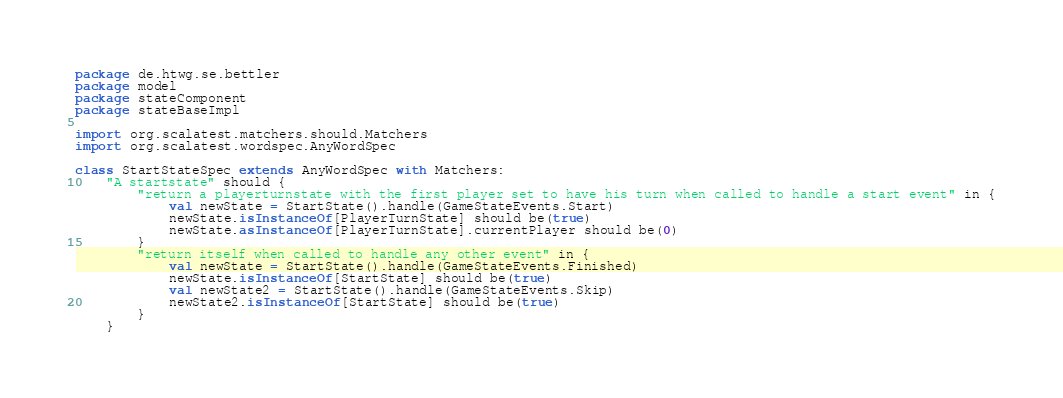Convert code to text. <code><loc_0><loc_0><loc_500><loc_500><_Scala_>package de.htwg.se.bettler
package model
package stateComponent
package stateBaseImpl

import org.scalatest.matchers.should.Matchers
import org.scalatest.wordspec.AnyWordSpec

class StartStateSpec extends AnyWordSpec with Matchers:
    "A startstate" should {
        "return a playerturnstate with the first player set to have his turn when called to handle a start event" in {
            val newState = StartState().handle(GameStateEvents.Start)
            newState.isInstanceOf[PlayerTurnState] should be(true)
            newState.asInstanceOf[PlayerTurnState].currentPlayer should be(0)
        }
        "return itself when called to handle any other event" in {
            val newState = StartState().handle(GameStateEvents.Finished)
            newState.isInstanceOf[StartState] should be(true)
            val newState2 = StartState().handle(GameStateEvents.Skip)
            newState2.isInstanceOf[StartState] should be(true)
        }
    }</code> 